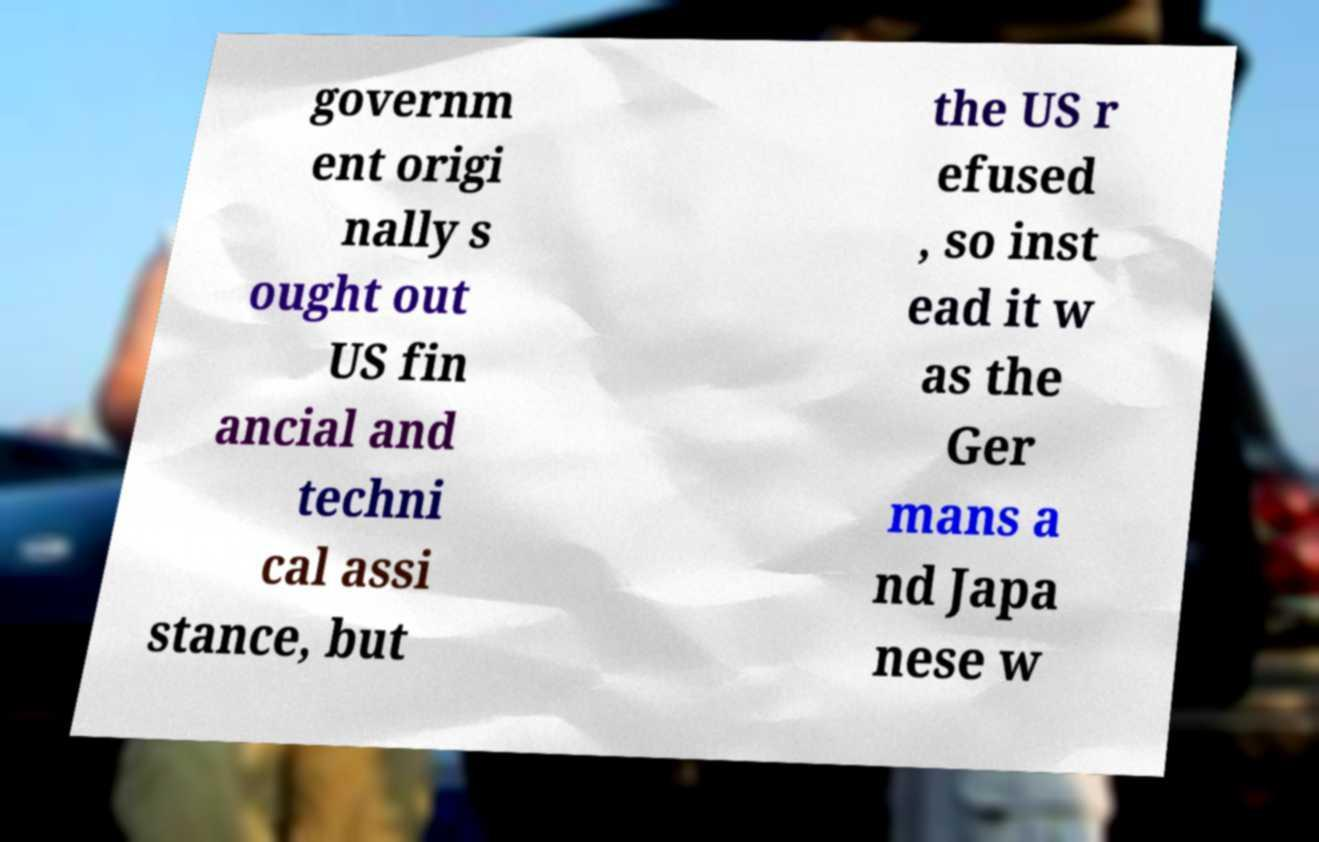I need the written content from this picture converted into text. Can you do that? governm ent origi nally s ought out US fin ancial and techni cal assi stance, but the US r efused , so inst ead it w as the Ger mans a nd Japa nese w 